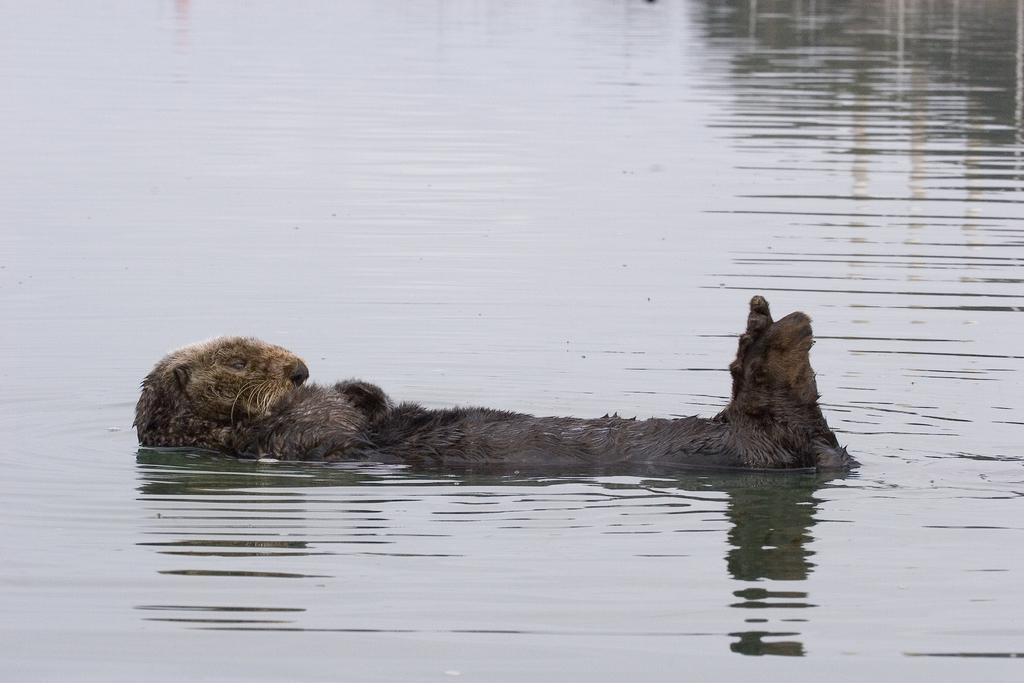What type of animal is present in the image? There is an animal in the image, but the specific type of animal is not mentioned in the provided facts. What is the animal doing in the image? The animal is laying on the water. What type of society does the animal belong to in the image? There is no information about the animal belonging to any society in the image. What brand of toothpaste is the animal using in the image? There is no toothpaste present in the image, and therefore the animal cannot be using any toothpaste. 